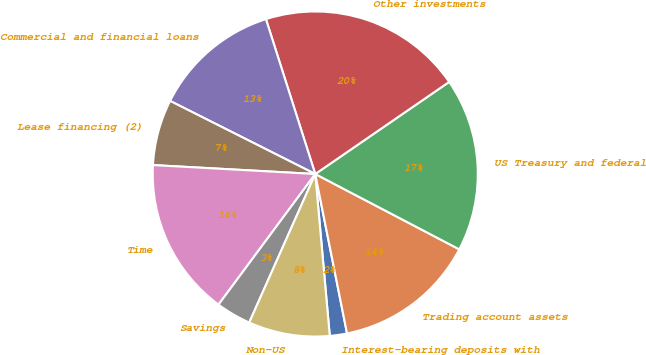Convert chart to OTSL. <chart><loc_0><loc_0><loc_500><loc_500><pie_chart><fcel>Interest-bearing deposits with<fcel>Trading account assets<fcel>US Treasury and federal<fcel>Other investments<fcel>Commercial and financial loans<fcel>Lease financing (2)<fcel>Time<fcel>Savings<fcel>Non-US<nl><fcel>1.71%<fcel>14.2%<fcel>17.26%<fcel>20.32%<fcel>12.67%<fcel>6.55%<fcel>15.73%<fcel>3.49%<fcel>8.08%<nl></chart> 